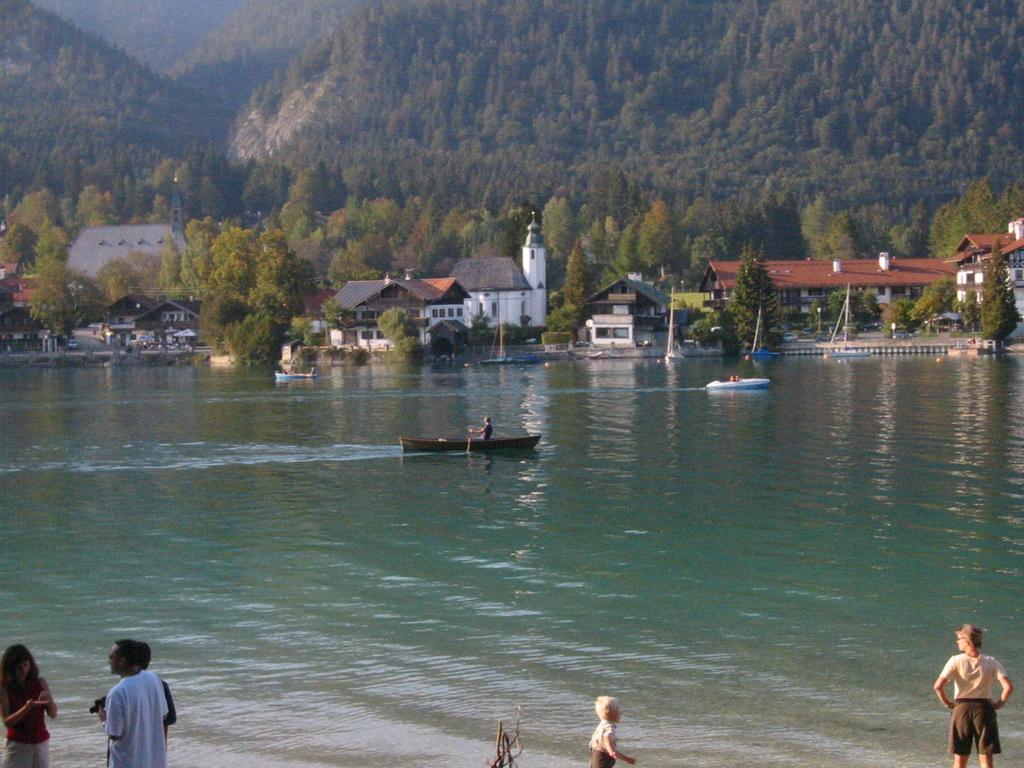How would you summarize this image in a sentence or two? In this image I can see people among them some are on boats. These boots are on the water. In the background I can see trees, buildings and other objects. 